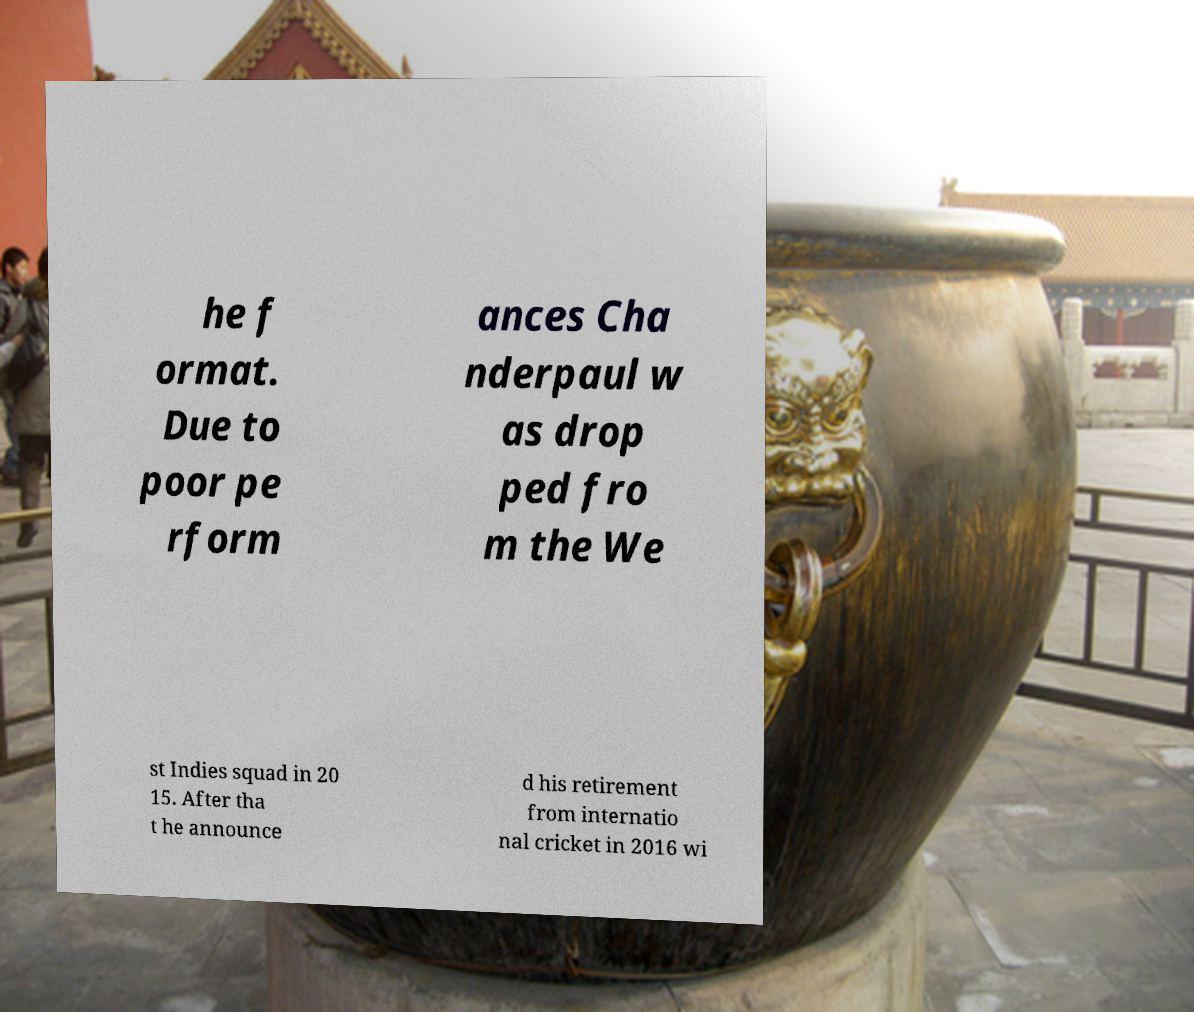Could you assist in decoding the text presented in this image and type it out clearly? he f ormat. Due to poor pe rform ances Cha nderpaul w as drop ped fro m the We st Indies squad in 20 15. After tha t he announce d his retirement from internatio nal cricket in 2016 wi 